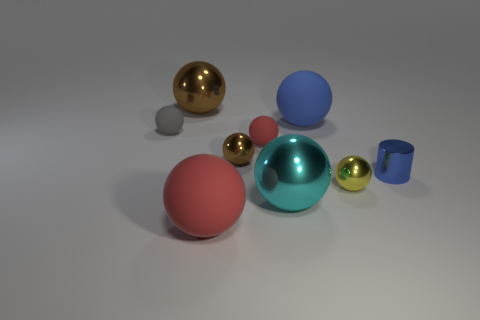Subtract 3 spheres. How many spheres are left? 5 Subtract all gray balls. How many balls are left? 7 Subtract all cyan balls. How many balls are left? 7 Subtract all red balls. Subtract all yellow cylinders. How many balls are left? 6 Add 1 tiny red spheres. How many objects exist? 10 Subtract all cylinders. How many objects are left? 8 Subtract all large blue objects. Subtract all brown objects. How many objects are left? 6 Add 4 large brown things. How many large brown things are left? 5 Add 6 small cyan cylinders. How many small cyan cylinders exist? 6 Subtract 1 gray balls. How many objects are left? 8 